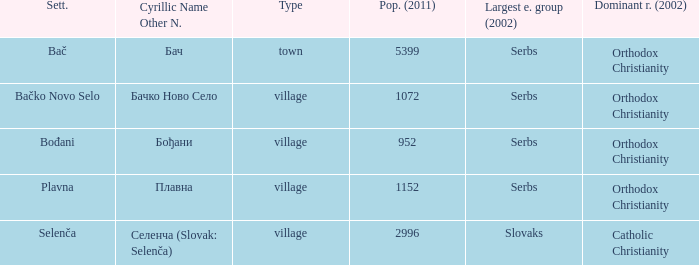What is the ethnic majority in the only town? Serbs. 